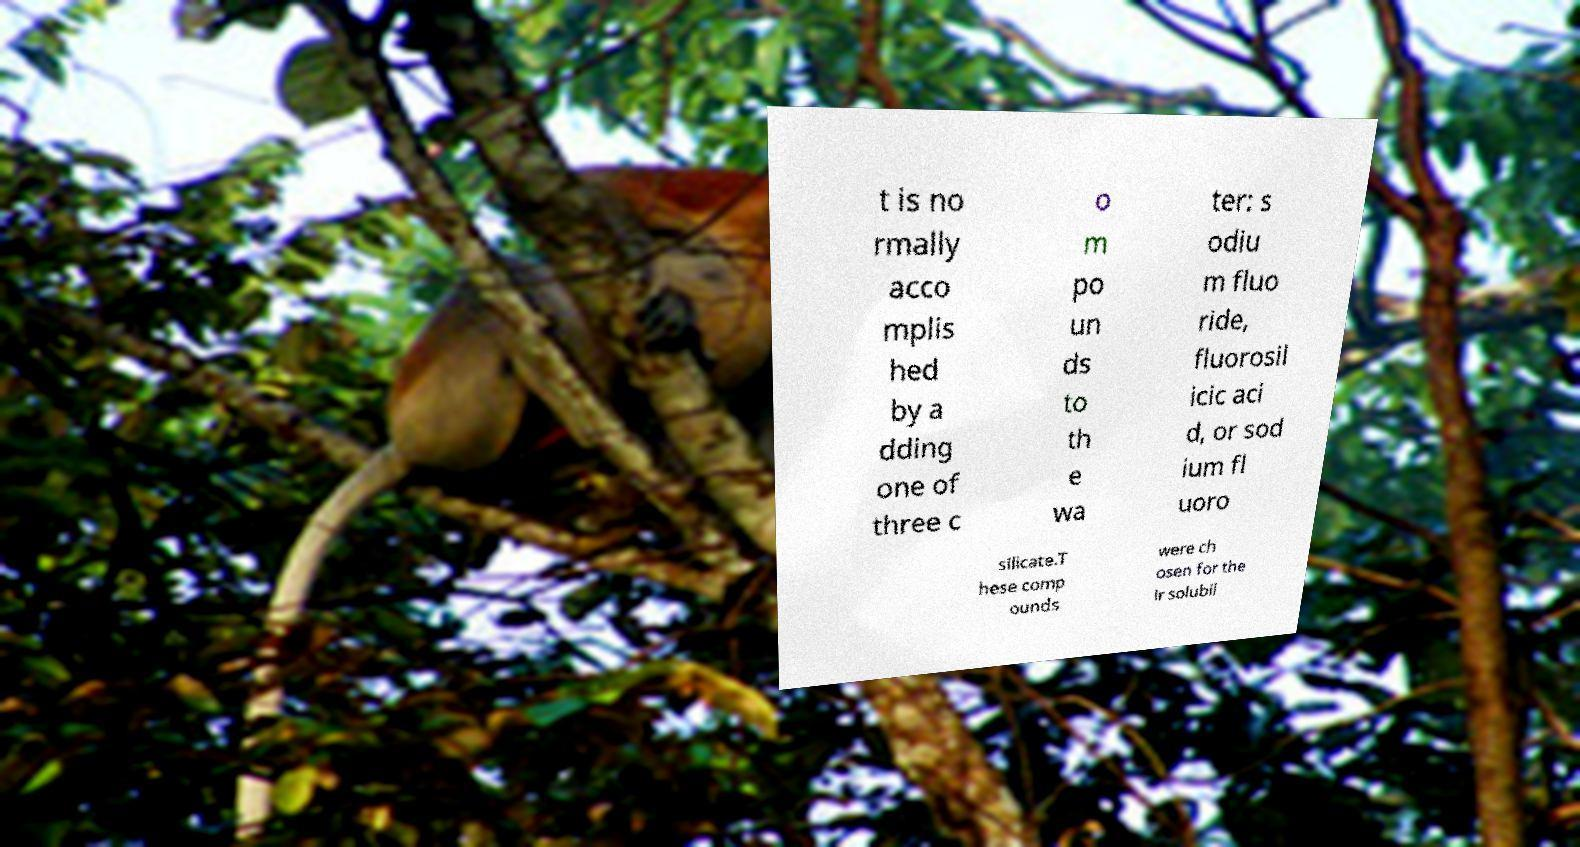Could you assist in decoding the text presented in this image and type it out clearly? t is no rmally acco mplis hed by a dding one of three c o m po un ds to th e wa ter: s odiu m fluo ride, fluorosil icic aci d, or sod ium fl uoro silicate.T hese comp ounds were ch osen for the ir solubil 